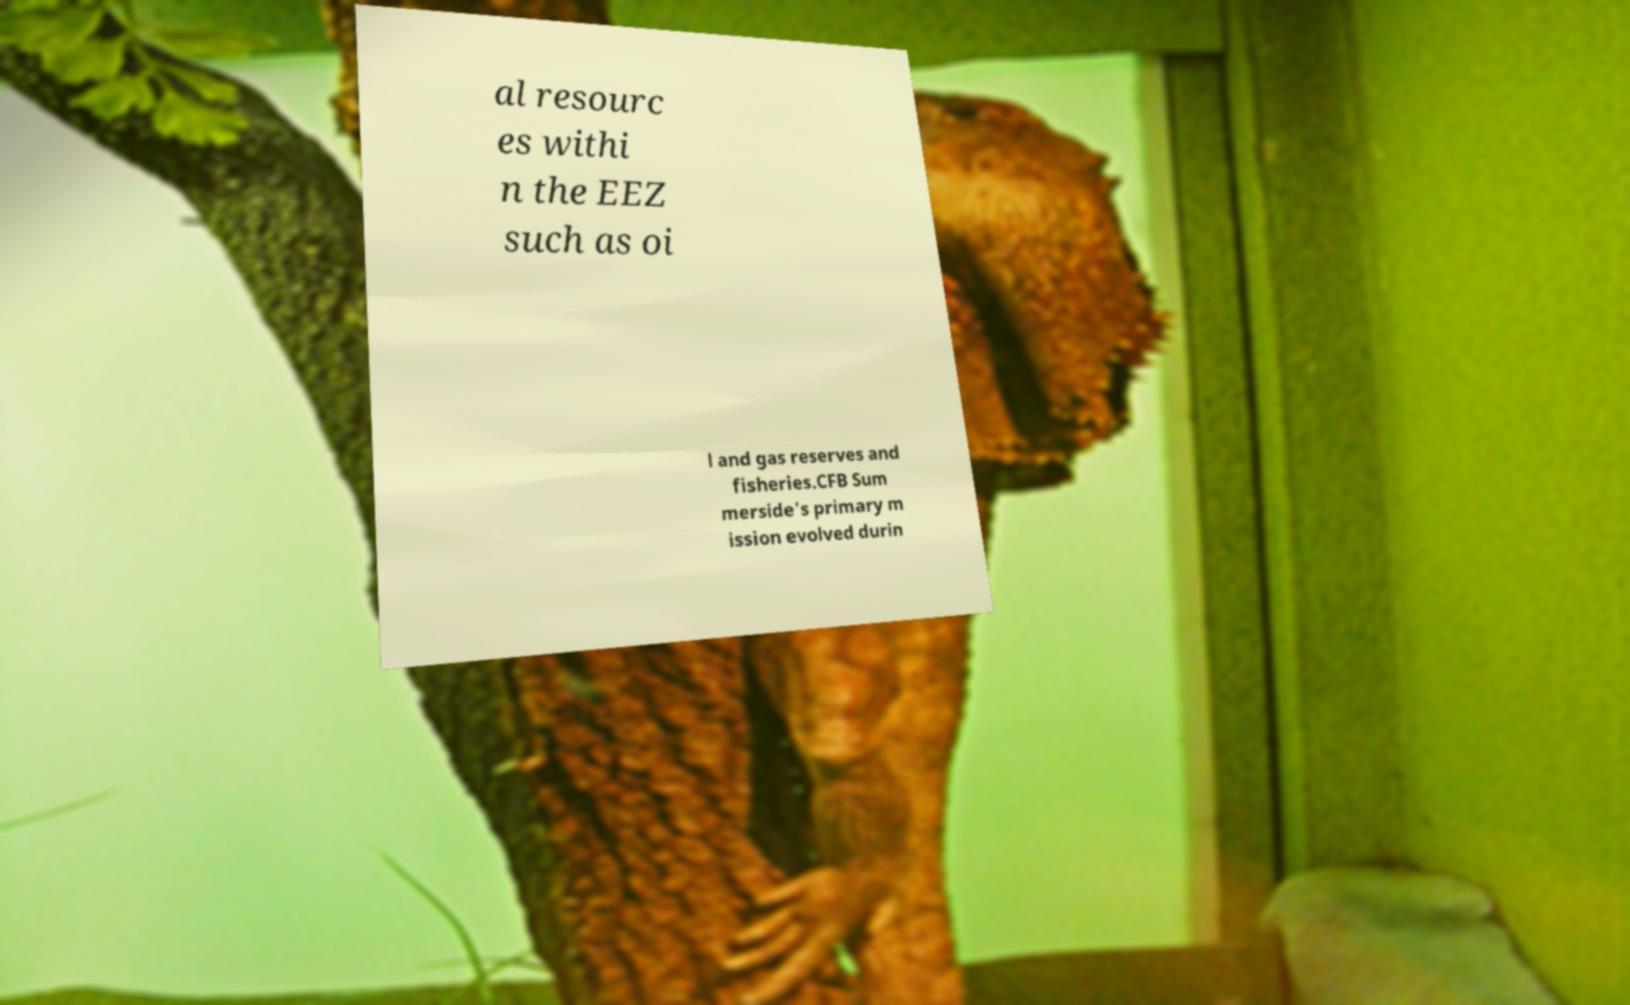Could you assist in decoding the text presented in this image and type it out clearly? al resourc es withi n the EEZ such as oi l and gas reserves and fisheries.CFB Sum merside's primary m ission evolved durin 